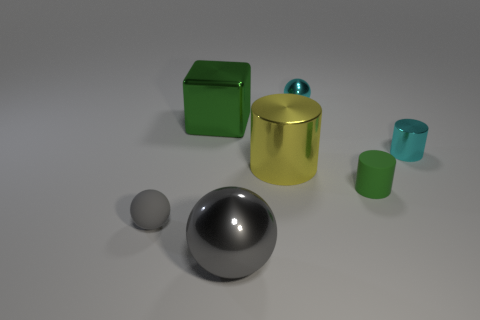Add 1 tiny cyan cylinders. How many objects exist? 8 Subtract all cubes. How many objects are left? 6 Add 6 spheres. How many spheres exist? 9 Subtract 0 gray cubes. How many objects are left? 7 Subtract all shiny cylinders. Subtract all big balls. How many objects are left? 4 Add 1 big shiny cylinders. How many big shiny cylinders are left? 2 